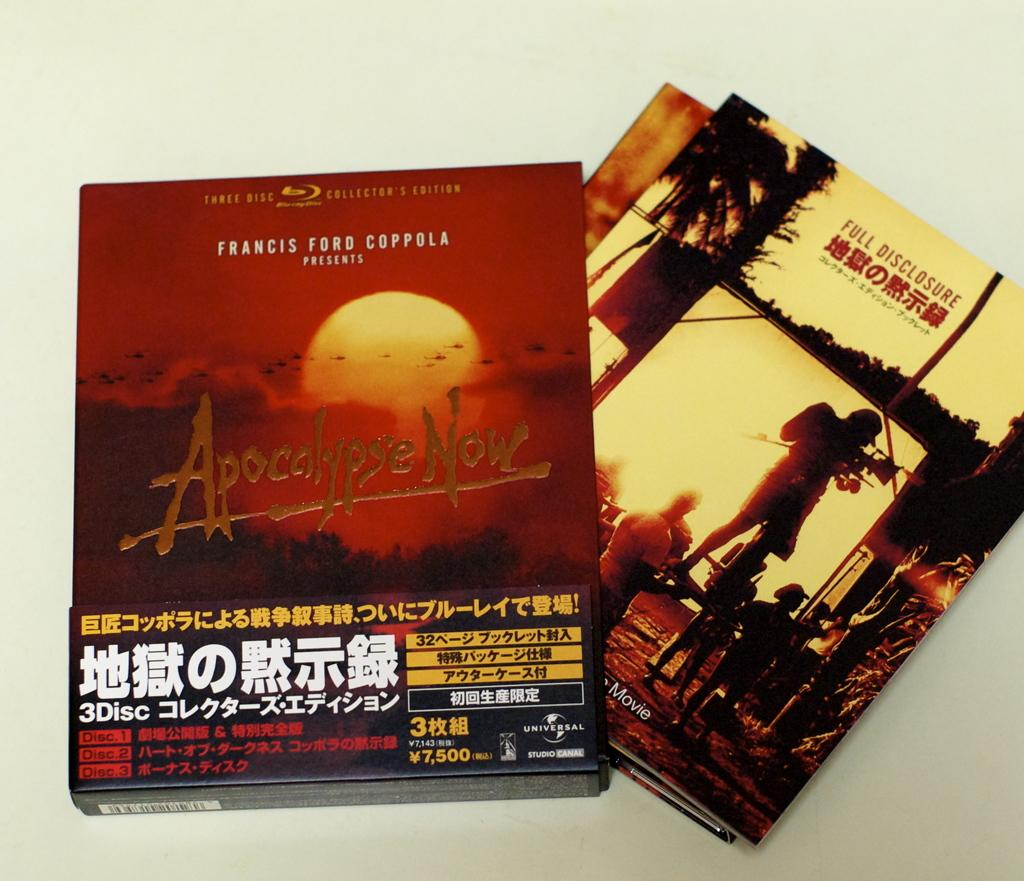<image>
Summarize the visual content of the image. a movie called Apocalypse now next to another movie 